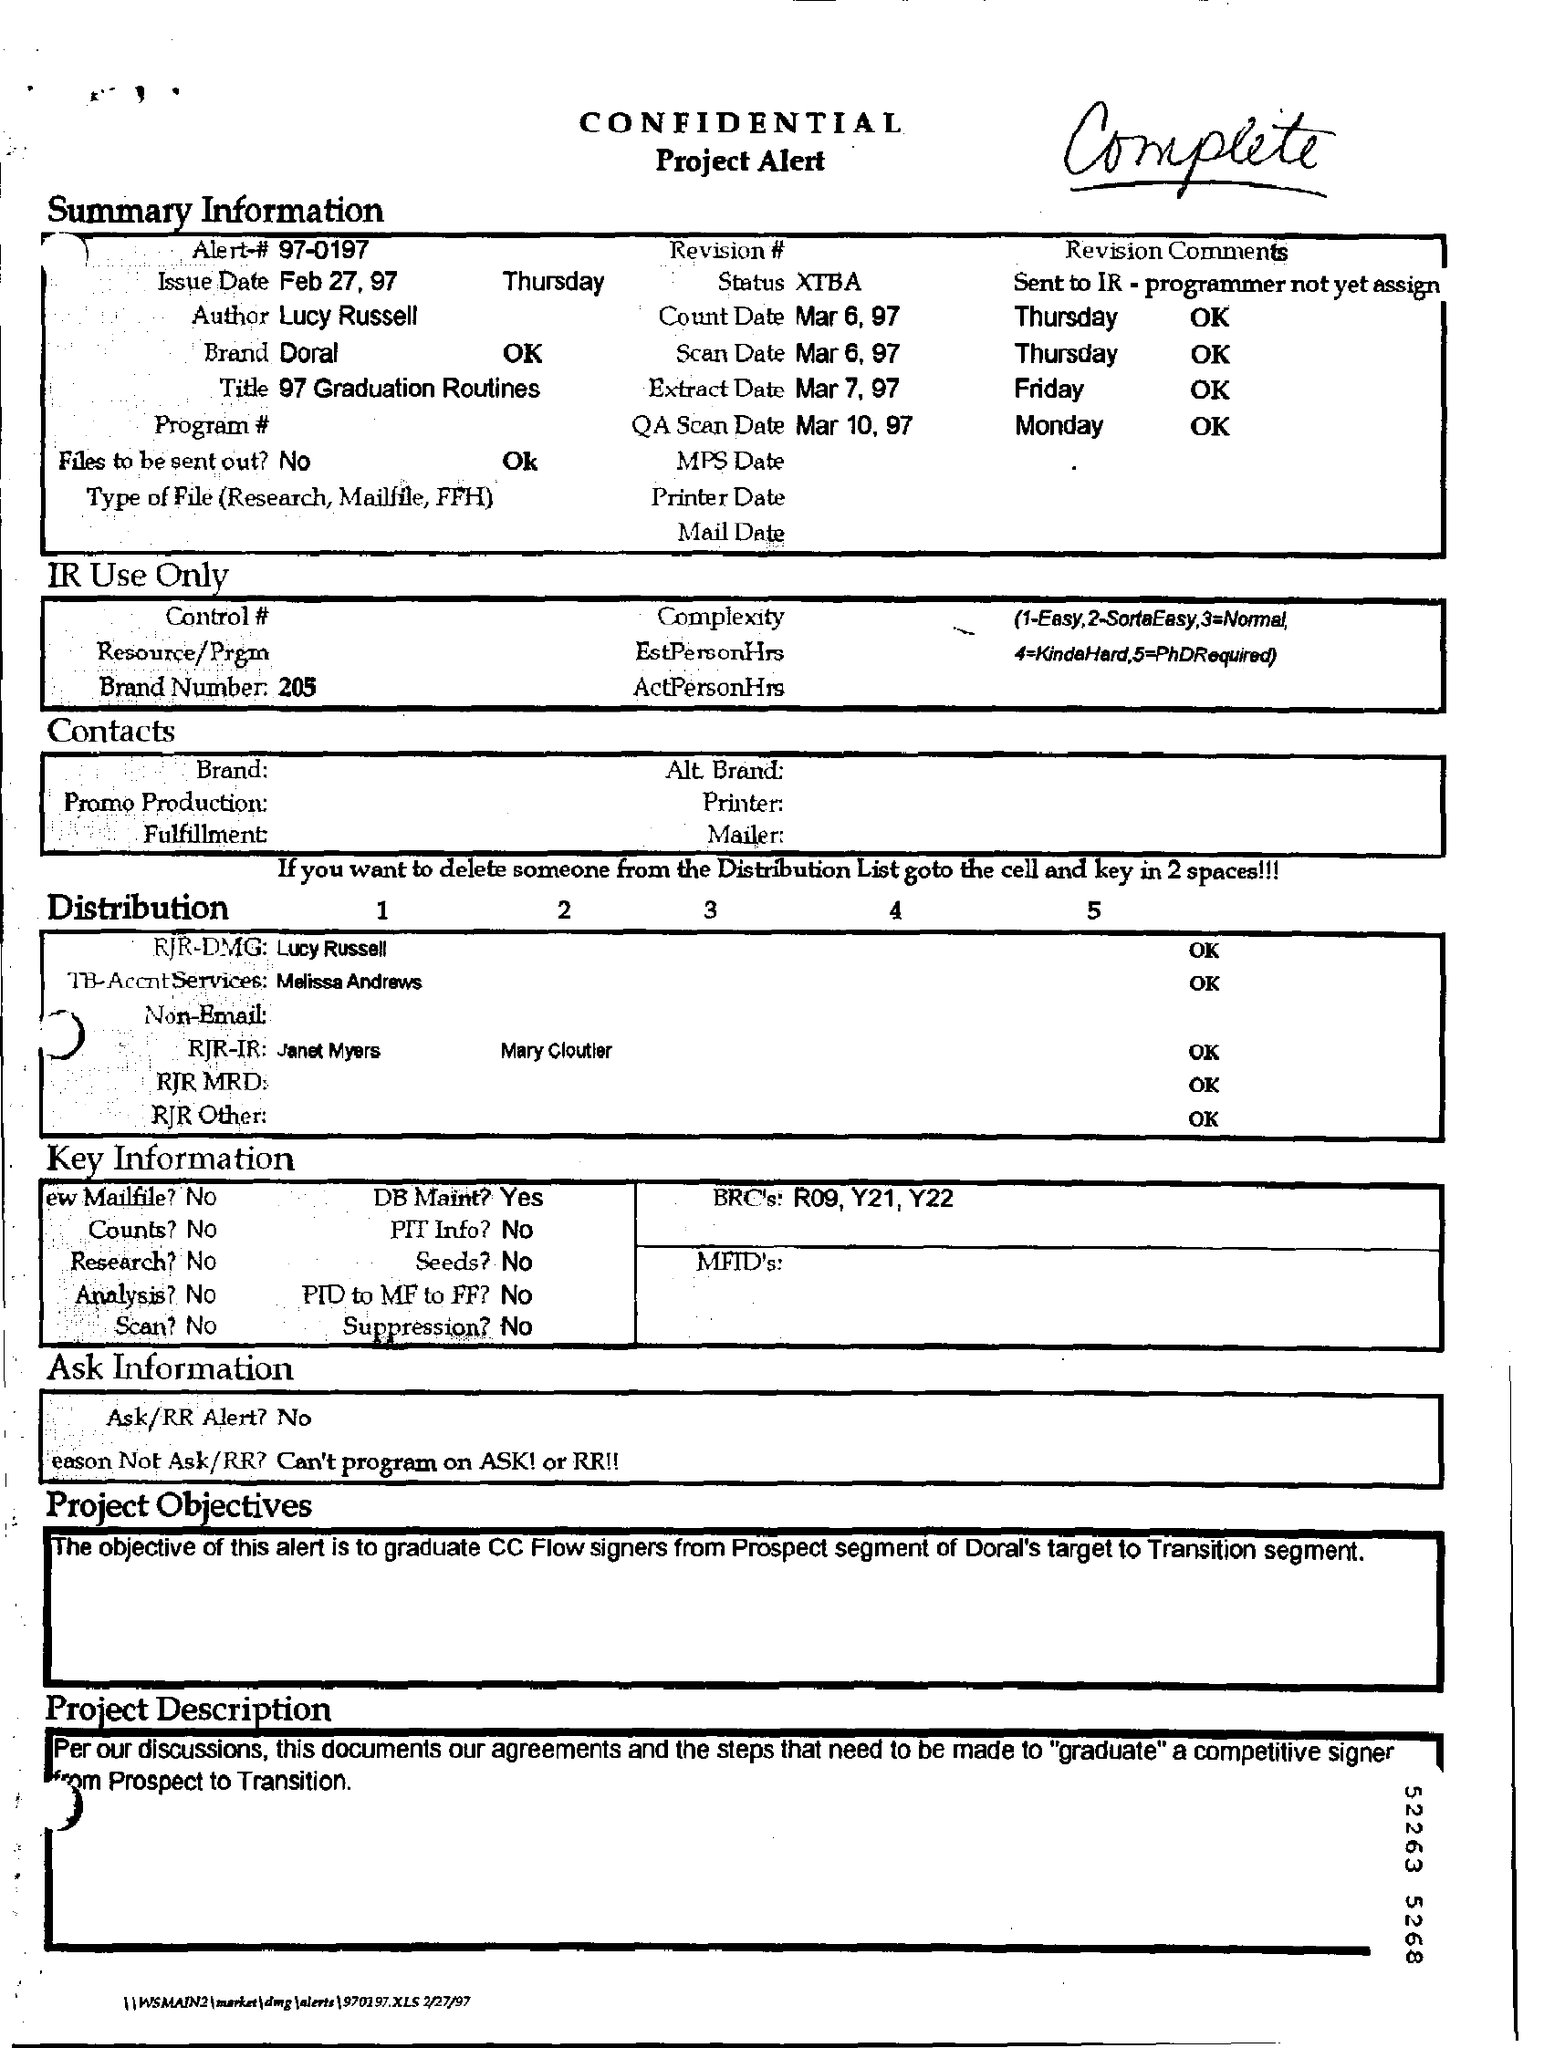What is the Alert - #?
Offer a terse response. 97-0197. Who is the Author?
Provide a short and direct response. Lucy Russell. What is the Brand?
Offer a very short reply. Doral. What is the Status?
Offer a very short reply. XTBA. What is the Count Date?
Your answer should be compact. Mar 6, 97. What is the Scan Date?
Ensure brevity in your answer.  Mar 6, 97. What is the QA Scan Date?
Your answer should be compact. Mar 10, 97. 